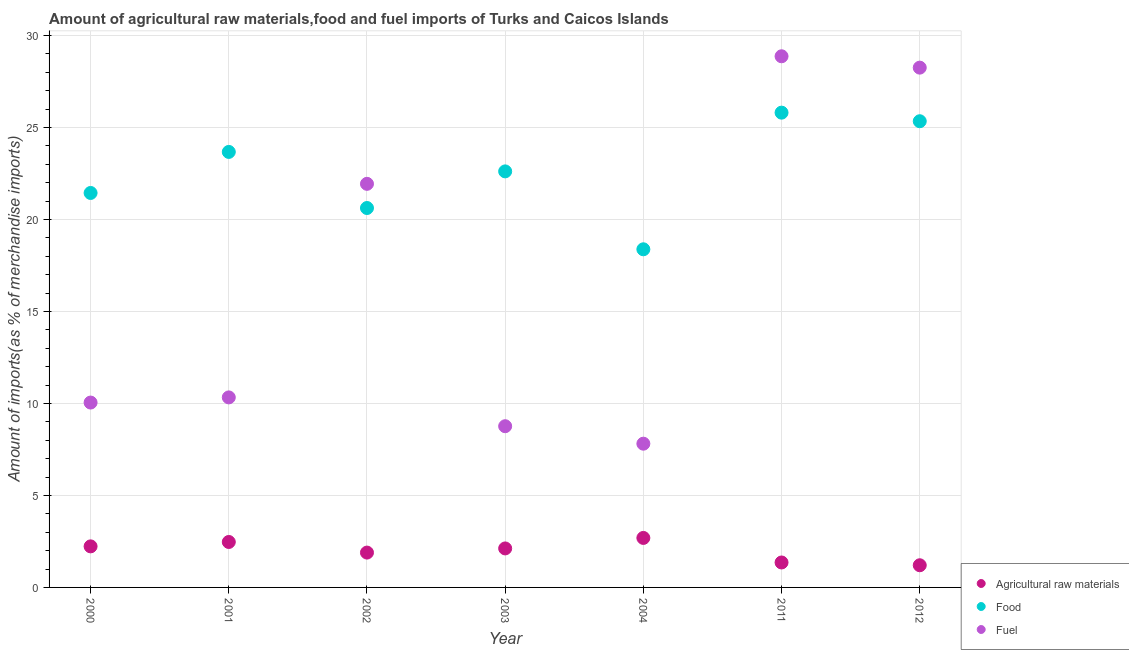How many different coloured dotlines are there?
Provide a succinct answer. 3. What is the percentage of raw materials imports in 2004?
Your answer should be compact. 2.69. Across all years, what is the maximum percentage of fuel imports?
Offer a very short reply. 28.87. Across all years, what is the minimum percentage of fuel imports?
Ensure brevity in your answer.  7.81. In which year was the percentage of fuel imports maximum?
Your response must be concise. 2011. What is the total percentage of raw materials imports in the graph?
Keep it short and to the point. 13.97. What is the difference between the percentage of raw materials imports in 2001 and that in 2011?
Provide a short and direct response. 1.11. What is the difference between the percentage of food imports in 2011 and the percentage of fuel imports in 2003?
Give a very brief answer. 17.04. What is the average percentage of raw materials imports per year?
Your answer should be compact. 2. In the year 2000, what is the difference between the percentage of raw materials imports and percentage of food imports?
Offer a terse response. -19.21. In how many years, is the percentage of fuel imports greater than 13 %?
Your answer should be compact. 3. What is the ratio of the percentage of fuel imports in 2002 to that in 2003?
Your answer should be compact. 2.5. Is the percentage of raw materials imports in 2000 less than that in 2002?
Give a very brief answer. No. What is the difference between the highest and the second highest percentage of raw materials imports?
Your response must be concise. 0.22. What is the difference between the highest and the lowest percentage of raw materials imports?
Offer a terse response. 1.49. In how many years, is the percentage of food imports greater than the average percentage of food imports taken over all years?
Your answer should be compact. 4. Does the percentage of fuel imports monotonically increase over the years?
Offer a very short reply. No. Is the percentage of raw materials imports strictly greater than the percentage of food imports over the years?
Your response must be concise. No. Is the percentage of raw materials imports strictly less than the percentage of fuel imports over the years?
Your response must be concise. Yes. How many dotlines are there?
Your response must be concise. 3. What is the difference between two consecutive major ticks on the Y-axis?
Give a very brief answer. 5. Are the values on the major ticks of Y-axis written in scientific E-notation?
Your answer should be very brief. No. Does the graph contain grids?
Your answer should be compact. Yes. What is the title of the graph?
Your answer should be compact. Amount of agricultural raw materials,food and fuel imports of Turks and Caicos Islands. What is the label or title of the Y-axis?
Provide a short and direct response. Amount of imports(as % of merchandise imports). What is the Amount of imports(as % of merchandise imports) in Agricultural raw materials in 2000?
Offer a terse response. 2.23. What is the Amount of imports(as % of merchandise imports) in Food in 2000?
Give a very brief answer. 21.44. What is the Amount of imports(as % of merchandise imports) of Fuel in 2000?
Give a very brief answer. 10.05. What is the Amount of imports(as % of merchandise imports) in Agricultural raw materials in 2001?
Give a very brief answer. 2.47. What is the Amount of imports(as % of merchandise imports) in Food in 2001?
Ensure brevity in your answer.  23.67. What is the Amount of imports(as % of merchandise imports) of Fuel in 2001?
Give a very brief answer. 10.33. What is the Amount of imports(as % of merchandise imports) of Agricultural raw materials in 2002?
Offer a terse response. 1.89. What is the Amount of imports(as % of merchandise imports) in Food in 2002?
Your answer should be very brief. 20.62. What is the Amount of imports(as % of merchandise imports) of Fuel in 2002?
Your answer should be compact. 21.94. What is the Amount of imports(as % of merchandise imports) of Agricultural raw materials in 2003?
Your answer should be compact. 2.12. What is the Amount of imports(as % of merchandise imports) in Food in 2003?
Ensure brevity in your answer.  22.62. What is the Amount of imports(as % of merchandise imports) of Fuel in 2003?
Your answer should be compact. 8.76. What is the Amount of imports(as % of merchandise imports) of Agricultural raw materials in 2004?
Ensure brevity in your answer.  2.69. What is the Amount of imports(as % of merchandise imports) in Food in 2004?
Offer a terse response. 18.38. What is the Amount of imports(as % of merchandise imports) in Fuel in 2004?
Make the answer very short. 7.81. What is the Amount of imports(as % of merchandise imports) in Agricultural raw materials in 2011?
Provide a short and direct response. 1.36. What is the Amount of imports(as % of merchandise imports) in Food in 2011?
Give a very brief answer. 25.81. What is the Amount of imports(as % of merchandise imports) of Fuel in 2011?
Provide a succinct answer. 28.87. What is the Amount of imports(as % of merchandise imports) in Agricultural raw materials in 2012?
Give a very brief answer. 1.21. What is the Amount of imports(as % of merchandise imports) in Food in 2012?
Offer a very short reply. 25.34. What is the Amount of imports(as % of merchandise imports) in Fuel in 2012?
Offer a very short reply. 28.25. Across all years, what is the maximum Amount of imports(as % of merchandise imports) in Agricultural raw materials?
Provide a succinct answer. 2.69. Across all years, what is the maximum Amount of imports(as % of merchandise imports) in Food?
Your answer should be compact. 25.81. Across all years, what is the maximum Amount of imports(as % of merchandise imports) of Fuel?
Your answer should be compact. 28.87. Across all years, what is the minimum Amount of imports(as % of merchandise imports) in Agricultural raw materials?
Give a very brief answer. 1.21. Across all years, what is the minimum Amount of imports(as % of merchandise imports) of Food?
Your response must be concise. 18.38. Across all years, what is the minimum Amount of imports(as % of merchandise imports) of Fuel?
Your response must be concise. 7.81. What is the total Amount of imports(as % of merchandise imports) in Agricultural raw materials in the graph?
Offer a very short reply. 13.97. What is the total Amount of imports(as % of merchandise imports) of Food in the graph?
Your answer should be compact. 157.88. What is the total Amount of imports(as % of merchandise imports) in Fuel in the graph?
Ensure brevity in your answer.  116.02. What is the difference between the Amount of imports(as % of merchandise imports) in Agricultural raw materials in 2000 and that in 2001?
Make the answer very short. -0.24. What is the difference between the Amount of imports(as % of merchandise imports) in Food in 2000 and that in 2001?
Offer a terse response. -2.23. What is the difference between the Amount of imports(as % of merchandise imports) of Fuel in 2000 and that in 2001?
Provide a succinct answer. -0.28. What is the difference between the Amount of imports(as % of merchandise imports) of Agricultural raw materials in 2000 and that in 2002?
Your answer should be compact. 0.34. What is the difference between the Amount of imports(as % of merchandise imports) of Food in 2000 and that in 2002?
Give a very brief answer. 0.82. What is the difference between the Amount of imports(as % of merchandise imports) of Fuel in 2000 and that in 2002?
Give a very brief answer. -11.89. What is the difference between the Amount of imports(as % of merchandise imports) of Agricultural raw materials in 2000 and that in 2003?
Provide a succinct answer. 0.11. What is the difference between the Amount of imports(as % of merchandise imports) in Food in 2000 and that in 2003?
Your answer should be compact. -1.17. What is the difference between the Amount of imports(as % of merchandise imports) in Fuel in 2000 and that in 2003?
Your answer should be very brief. 1.29. What is the difference between the Amount of imports(as % of merchandise imports) of Agricultural raw materials in 2000 and that in 2004?
Ensure brevity in your answer.  -0.46. What is the difference between the Amount of imports(as % of merchandise imports) of Food in 2000 and that in 2004?
Offer a terse response. 3.06. What is the difference between the Amount of imports(as % of merchandise imports) in Fuel in 2000 and that in 2004?
Your response must be concise. 2.24. What is the difference between the Amount of imports(as % of merchandise imports) in Agricultural raw materials in 2000 and that in 2011?
Give a very brief answer. 0.88. What is the difference between the Amount of imports(as % of merchandise imports) of Food in 2000 and that in 2011?
Offer a very short reply. -4.37. What is the difference between the Amount of imports(as % of merchandise imports) of Fuel in 2000 and that in 2011?
Offer a terse response. -18.82. What is the difference between the Amount of imports(as % of merchandise imports) in Agricultural raw materials in 2000 and that in 2012?
Give a very brief answer. 1.03. What is the difference between the Amount of imports(as % of merchandise imports) in Food in 2000 and that in 2012?
Your answer should be compact. -3.9. What is the difference between the Amount of imports(as % of merchandise imports) in Fuel in 2000 and that in 2012?
Ensure brevity in your answer.  -18.21. What is the difference between the Amount of imports(as % of merchandise imports) in Agricultural raw materials in 2001 and that in 2002?
Offer a terse response. 0.58. What is the difference between the Amount of imports(as % of merchandise imports) of Food in 2001 and that in 2002?
Provide a short and direct response. 3.05. What is the difference between the Amount of imports(as % of merchandise imports) of Fuel in 2001 and that in 2002?
Your answer should be very brief. -11.61. What is the difference between the Amount of imports(as % of merchandise imports) in Agricultural raw materials in 2001 and that in 2003?
Provide a short and direct response. 0.35. What is the difference between the Amount of imports(as % of merchandise imports) in Food in 2001 and that in 2003?
Ensure brevity in your answer.  1.06. What is the difference between the Amount of imports(as % of merchandise imports) in Fuel in 2001 and that in 2003?
Offer a very short reply. 1.57. What is the difference between the Amount of imports(as % of merchandise imports) of Agricultural raw materials in 2001 and that in 2004?
Keep it short and to the point. -0.22. What is the difference between the Amount of imports(as % of merchandise imports) in Food in 2001 and that in 2004?
Offer a terse response. 5.29. What is the difference between the Amount of imports(as % of merchandise imports) in Fuel in 2001 and that in 2004?
Your answer should be very brief. 2.52. What is the difference between the Amount of imports(as % of merchandise imports) in Agricultural raw materials in 2001 and that in 2011?
Provide a short and direct response. 1.11. What is the difference between the Amount of imports(as % of merchandise imports) of Food in 2001 and that in 2011?
Your response must be concise. -2.13. What is the difference between the Amount of imports(as % of merchandise imports) of Fuel in 2001 and that in 2011?
Offer a very short reply. -18.54. What is the difference between the Amount of imports(as % of merchandise imports) in Agricultural raw materials in 2001 and that in 2012?
Your answer should be compact. 1.27. What is the difference between the Amount of imports(as % of merchandise imports) in Food in 2001 and that in 2012?
Give a very brief answer. -1.67. What is the difference between the Amount of imports(as % of merchandise imports) of Fuel in 2001 and that in 2012?
Give a very brief answer. -17.93. What is the difference between the Amount of imports(as % of merchandise imports) of Agricultural raw materials in 2002 and that in 2003?
Your answer should be very brief. -0.23. What is the difference between the Amount of imports(as % of merchandise imports) in Food in 2002 and that in 2003?
Make the answer very short. -1.99. What is the difference between the Amount of imports(as % of merchandise imports) of Fuel in 2002 and that in 2003?
Keep it short and to the point. 13.18. What is the difference between the Amount of imports(as % of merchandise imports) in Agricultural raw materials in 2002 and that in 2004?
Keep it short and to the point. -0.8. What is the difference between the Amount of imports(as % of merchandise imports) in Food in 2002 and that in 2004?
Make the answer very short. 2.24. What is the difference between the Amount of imports(as % of merchandise imports) in Fuel in 2002 and that in 2004?
Keep it short and to the point. 14.13. What is the difference between the Amount of imports(as % of merchandise imports) of Agricultural raw materials in 2002 and that in 2011?
Provide a succinct answer. 0.54. What is the difference between the Amount of imports(as % of merchandise imports) of Food in 2002 and that in 2011?
Your response must be concise. -5.18. What is the difference between the Amount of imports(as % of merchandise imports) in Fuel in 2002 and that in 2011?
Provide a succinct answer. -6.93. What is the difference between the Amount of imports(as % of merchandise imports) in Agricultural raw materials in 2002 and that in 2012?
Ensure brevity in your answer.  0.69. What is the difference between the Amount of imports(as % of merchandise imports) of Food in 2002 and that in 2012?
Keep it short and to the point. -4.72. What is the difference between the Amount of imports(as % of merchandise imports) of Fuel in 2002 and that in 2012?
Make the answer very short. -6.32. What is the difference between the Amount of imports(as % of merchandise imports) of Agricultural raw materials in 2003 and that in 2004?
Your answer should be compact. -0.57. What is the difference between the Amount of imports(as % of merchandise imports) of Food in 2003 and that in 2004?
Provide a short and direct response. 4.23. What is the difference between the Amount of imports(as % of merchandise imports) in Fuel in 2003 and that in 2004?
Provide a short and direct response. 0.95. What is the difference between the Amount of imports(as % of merchandise imports) in Agricultural raw materials in 2003 and that in 2011?
Your answer should be compact. 0.76. What is the difference between the Amount of imports(as % of merchandise imports) of Food in 2003 and that in 2011?
Provide a succinct answer. -3.19. What is the difference between the Amount of imports(as % of merchandise imports) of Fuel in 2003 and that in 2011?
Provide a short and direct response. -20.11. What is the difference between the Amount of imports(as % of merchandise imports) of Agricultural raw materials in 2003 and that in 2012?
Offer a very short reply. 0.91. What is the difference between the Amount of imports(as % of merchandise imports) in Food in 2003 and that in 2012?
Give a very brief answer. -2.73. What is the difference between the Amount of imports(as % of merchandise imports) of Fuel in 2003 and that in 2012?
Make the answer very short. -19.49. What is the difference between the Amount of imports(as % of merchandise imports) in Agricultural raw materials in 2004 and that in 2011?
Provide a short and direct response. 1.33. What is the difference between the Amount of imports(as % of merchandise imports) of Food in 2004 and that in 2011?
Your response must be concise. -7.43. What is the difference between the Amount of imports(as % of merchandise imports) of Fuel in 2004 and that in 2011?
Offer a very short reply. -21.06. What is the difference between the Amount of imports(as % of merchandise imports) of Agricultural raw materials in 2004 and that in 2012?
Keep it short and to the point. 1.49. What is the difference between the Amount of imports(as % of merchandise imports) in Food in 2004 and that in 2012?
Provide a short and direct response. -6.96. What is the difference between the Amount of imports(as % of merchandise imports) in Fuel in 2004 and that in 2012?
Offer a very short reply. -20.44. What is the difference between the Amount of imports(as % of merchandise imports) in Agricultural raw materials in 2011 and that in 2012?
Your answer should be compact. 0.15. What is the difference between the Amount of imports(as % of merchandise imports) of Food in 2011 and that in 2012?
Provide a short and direct response. 0.47. What is the difference between the Amount of imports(as % of merchandise imports) of Fuel in 2011 and that in 2012?
Your response must be concise. 0.62. What is the difference between the Amount of imports(as % of merchandise imports) in Agricultural raw materials in 2000 and the Amount of imports(as % of merchandise imports) in Food in 2001?
Ensure brevity in your answer.  -21.44. What is the difference between the Amount of imports(as % of merchandise imports) in Agricultural raw materials in 2000 and the Amount of imports(as % of merchandise imports) in Fuel in 2001?
Make the answer very short. -8.1. What is the difference between the Amount of imports(as % of merchandise imports) of Food in 2000 and the Amount of imports(as % of merchandise imports) of Fuel in 2001?
Your answer should be very brief. 11.11. What is the difference between the Amount of imports(as % of merchandise imports) of Agricultural raw materials in 2000 and the Amount of imports(as % of merchandise imports) of Food in 2002?
Give a very brief answer. -18.39. What is the difference between the Amount of imports(as % of merchandise imports) in Agricultural raw materials in 2000 and the Amount of imports(as % of merchandise imports) in Fuel in 2002?
Offer a terse response. -19.71. What is the difference between the Amount of imports(as % of merchandise imports) of Food in 2000 and the Amount of imports(as % of merchandise imports) of Fuel in 2002?
Ensure brevity in your answer.  -0.5. What is the difference between the Amount of imports(as % of merchandise imports) in Agricultural raw materials in 2000 and the Amount of imports(as % of merchandise imports) in Food in 2003?
Make the answer very short. -20.38. What is the difference between the Amount of imports(as % of merchandise imports) of Agricultural raw materials in 2000 and the Amount of imports(as % of merchandise imports) of Fuel in 2003?
Give a very brief answer. -6.53. What is the difference between the Amount of imports(as % of merchandise imports) of Food in 2000 and the Amount of imports(as % of merchandise imports) of Fuel in 2003?
Offer a very short reply. 12.68. What is the difference between the Amount of imports(as % of merchandise imports) of Agricultural raw materials in 2000 and the Amount of imports(as % of merchandise imports) of Food in 2004?
Provide a short and direct response. -16.15. What is the difference between the Amount of imports(as % of merchandise imports) in Agricultural raw materials in 2000 and the Amount of imports(as % of merchandise imports) in Fuel in 2004?
Keep it short and to the point. -5.58. What is the difference between the Amount of imports(as % of merchandise imports) of Food in 2000 and the Amount of imports(as % of merchandise imports) of Fuel in 2004?
Provide a short and direct response. 13.63. What is the difference between the Amount of imports(as % of merchandise imports) of Agricultural raw materials in 2000 and the Amount of imports(as % of merchandise imports) of Food in 2011?
Provide a short and direct response. -23.58. What is the difference between the Amount of imports(as % of merchandise imports) in Agricultural raw materials in 2000 and the Amount of imports(as % of merchandise imports) in Fuel in 2011?
Your response must be concise. -26.64. What is the difference between the Amount of imports(as % of merchandise imports) in Food in 2000 and the Amount of imports(as % of merchandise imports) in Fuel in 2011?
Provide a short and direct response. -7.43. What is the difference between the Amount of imports(as % of merchandise imports) of Agricultural raw materials in 2000 and the Amount of imports(as % of merchandise imports) of Food in 2012?
Provide a short and direct response. -23.11. What is the difference between the Amount of imports(as % of merchandise imports) of Agricultural raw materials in 2000 and the Amount of imports(as % of merchandise imports) of Fuel in 2012?
Provide a short and direct response. -26.02. What is the difference between the Amount of imports(as % of merchandise imports) in Food in 2000 and the Amount of imports(as % of merchandise imports) in Fuel in 2012?
Your response must be concise. -6.81. What is the difference between the Amount of imports(as % of merchandise imports) of Agricultural raw materials in 2001 and the Amount of imports(as % of merchandise imports) of Food in 2002?
Your response must be concise. -18.15. What is the difference between the Amount of imports(as % of merchandise imports) in Agricultural raw materials in 2001 and the Amount of imports(as % of merchandise imports) in Fuel in 2002?
Provide a succinct answer. -19.47. What is the difference between the Amount of imports(as % of merchandise imports) of Food in 2001 and the Amount of imports(as % of merchandise imports) of Fuel in 2002?
Make the answer very short. 1.73. What is the difference between the Amount of imports(as % of merchandise imports) in Agricultural raw materials in 2001 and the Amount of imports(as % of merchandise imports) in Food in 2003?
Offer a terse response. -20.14. What is the difference between the Amount of imports(as % of merchandise imports) in Agricultural raw materials in 2001 and the Amount of imports(as % of merchandise imports) in Fuel in 2003?
Ensure brevity in your answer.  -6.29. What is the difference between the Amount of imports(as % of merchandise imports) of Food in 2001 and the Amount of imports(as % of merchandise imports) of Fuel in 2003?
Provide a short and direct response. 14.91. What is the difference between the Amount of imports(as % of merchandise imports) of Agricultural raw materials in 2001 and the Amount of imports(as % of merchandise imports) of Food in 2004?
Your response must be concise. -15.91. What is the difference between the Amount of imports(as % of merchandise imports) in Agricultural raw materials in 2001 and the Amount of imports(as % of merchandise imports) in Fuel in 2004?
Offer a very short reply. -5.34. What is the difference between the Amount of imports(as % of merchandise imports) in Food in 2001 and the Amount of imports(as % of merchandise imports) in Fuel in 2004?
Offer a terse response. 15.86. What is the difference between the Amount of imports(as % of merchandise imports) of Agricultural raw materials in 2001 and the Amount of imports(as % of merchandise imports) of Food in 2011?
Your response must be concise. -23.34. What is the difference between the Amount of imports(as % of merchandise imports) of Agricultural raw materials in 2001 and the Amount of imports(as % of merchandise imports) of Fuel in 2011?
Offer a very short reply. -26.4. What is the difference between the Amount of imports(as % of merchandise imports) of Food in 2001 and the Amount of imports(as % of merchandise imports) of Fuel in 2011?
Provide a succinct answer. -5.2. What is the difference between the Amount of imports(as % of merchandise imports) of Agricultural raw materials in 2001 and the Amount of imports(as % of merchandise imports) of Food in 2012?
Your response must be concise. -22.87. What is the difference between the Amount of imports(as % of merchandise imports) in Agricultural raw materials in 2001 and the Amount of imports(as % of merchandise imports) in Fuel in 2012?
Offer a terse response. -25.78. What is the difference between the Amount of imports(as % of merchandise imports) in Food in 2001 and the Amount of imports(as % of merchandise imports) in Fuel in 2012?
Offer a terse response. -4.58. What is the difference between the Amount of imports(as % of merchandise imports) of Agricultural raw materials in 2002 and the Amount of imports(as % of merchandise imports) of Food in 2003?
Keep it short and to the point. -20.72. What is the difference between the Amount of imports(as % of merchandise imports) in Agricultural raw materials in 2002 and the Amount of imports(as % of merchandise imports) in Fuel in 2003?
Your answer should be very brief. -6.87. What is the difference between the Amount of imports(as % of merchandise imports) in Food in 2002 and the Amount of imports(as % of merchandise imports) in Fuel in 2003?
Give a very brief answer. 11.86. What is the difference between the Amount of imports(as % of merchandise imports) of Agricultural raw materials in 2002 and the Amount of imports(as % of merchandise imports) of Food in 2004?
Make the answer very short. -16.49. What is the difference between the Amount of imports(as % of merchandise imports) of Agricultural raw materials in 2002 and the Amount of imports(as % of merchandise imports) of Fuel in 2004?
Make the answer very short. -5.92. What is the difference between the Amount of imports(as % of merchandise imports) in Food in 2002 and the Amount of imports(as % of merchandise imports) in Fuel in 2004?
Your answer should be very brief. 12.81. What is the difference between the Amount of imports(as % of merchandise imports) of Agricultural raw materials in 2002 and the Amount of imports(as % of merchandise imports) of Food in 2011?
Your answer should be very brief. -23.91. What is the difference between the Amount of imports(as % of merchandise imports) in Agricultural raw materials in 2002 and the Amount of imports(as % of merchandise imports) in Fuel in 2011?
Provide a succinct answer. -26.98. What is the difference between the Amount of imports(as % of merchandise imports) of Food in 2002 and the Amount of imports(as % of merchandise imports) of Fuel in 2011?
Your answer should be compact. -8.25. What is the difference between the Amount of imports(as % of merchandise imports) in Agricultural raw materials in 2002 and the Amount of imports(as % of merchandise imports) in Food in 2012?
Provide a short and direct response. -23.45. What is the difference between the Amount of imports(as % of merchandise imports) of Agricultural raw materials in 2002 and the Amount of imports(as % of merchandise imports) of Fuel in 2012?
Offer a terse response. -26.36. What is the difference between the Amount of imports(as % of merchandise imports) of Food in 2002 and the Amount of imports(as % of merchandise imports) of Fuel in 2012?
Provide a short and direct response. -7.63. What is the difference between the Amount of imports(as % of merchandise imports) of Agricultural raw materials in 2003 and the Amount of imports(as % of merchandise imports) of Food in 2004?
Offer a very short reply. -16.26. What is the difference between the Amount of imports(as % of merchandise imports) of Agricultural raw materials in 2003 and the Amount of imports(as % of merchandise imports) of Fuel in 2004?
Offer a very short reply. -5.69. What is the difference between the Amount of imports(as % of merchandise imports) of Food in 2003 and the Amount of imports(as % of merchandise imports) of Fuel in 2004?
Keep it short and to the point. 14.8. What is the difference between the Amount of imports(as % of merchandise imports) of Agricultural raw materials in 2003 and the Amount of imports(as % of merchandise imports) of Food in 2011?
Keep it short and to the point. -23.69. What is the difference between the Amount of imports(as % of merchandise imports) of Agricultural raw materials in 2003 and the Amount of imports(as % of merchandise imports) of Fuel in 2011?
Offer a very short reply. -26.75. What is the difference between the Amount of imports(as % of merchandise imports) in Food in 2003 and the Amount of imports(as % of merchandise imports) in Fuel in 2011?
Your answer should be very brief. -6.26. What is the difference between the Amount of imports(as % of merchandise imports) in Agricultural raw materials in 2003 and the Amount of imports(as % of merchandise imports) in Food in 2012?
Keep it short and to the point. -23.22. What is the difference between the Amount of imports(as % of merchandise imports) in Agricultural raw materials in 2003 and the Amount of imports(as % of merchandise imports) in Fuel in 2012?
Offer a very short reply. -26.13. What is the difference between the Amount of imports(as % of merchandise imports) in Food in 2003 and the Amount of imports(as % of merchandise imports) in Fuel in 2012?
Your answer should be compact. -5.64. What is the difference between the Amount of imports(as % of merchandise imports) in Agricultural raw materials in 2004 and the Amount of imports(as % of merchandise imports) in Food in 2011?
Give a very brief answer. -23.12. What is the difference between the Amount of imports(as % of merchandise imports) of Agricultural raw materials in 2004 and the Amount of imports(as % of merchandise imports) of Fuel in 2011?
Your answer should be very brief. -26.18. What is the difference between the Amount of imports(as % of merchandise imports) in Food in 2004 and the Amount of imports(as % of merchandise imports) in Fuel in 2011?
Provide a succinct answer. -10.49. What is the difference between the Amount of imports(as % of merchandise imports) of Agricultural raw materials in 2004 and the Amount of imports(as % of merchandise imports) of Food in 2012?
Keep it short and to the point. -22.65. What is the difference between the Amount of imports(as % of merchandise imports) in Agricultural raw materials in 2004 and the Amount of imports(as % of merchandise imports) in Fuel in 2012?
Ensure brevity in your answer.  -25.56. What is the difference between the Amount of imports(as % of merchandise imports) of Food in 2004 and the Amount of imports(as % of merchandise imports) of Fuel in 2012?
Your response must be concise. -9.87. What is the difference between the Amount of imports(as % of merchandise imports) of Agricultural raw materials in 2011 and the Amount of imports(as % of merchandise imports) of Food in 2012?
Offer a terse response. -23.99. What is the difference between the Amount of imports(as % of merchandise imports) in Agricultural raw materials in 2011 and the Amount of imports(as % of merchandise imports) in Fuel in 2012?
Your response must be concise. -26.9. What is the difference between the Amount of imports(as % of merchandise imports) in Food in 2011 and the Amount of imports(as % of merchandise imports) in Fuel in 2012?
Ensure brevity in your answer.  -2.45. What is the average Amount of imports(as % of merchandise imports) in Agricultural raw materials per year?
Give a very brief answer. 2. What is the average Amount of imports(as % of merchandise imports) of Food per year?
Your answer should be very brief. 22.55. What is the average Amount of imports(as % of merchandise imports) in Fuel per year?
Your response must be concise. 16.57. In the year 2000, what is the difference between the Amount of imports(as % of merchandise imports) of Agricultural raw materials and Amount of imports(as % of merchandise imports) of Food?
Provide a succinct answer. -19.21. In the year 2000, what is the difference between the Amount of imports(as % of merchandise imports) of Agricultural raw materials and Amount of imports(as % of merchandise imports) of Fuel?
Provide a succinct answer. -7.82. In the year 2000, what is the difference between the Amount of imports(as % of merchandise imports) of Food and Amount of imports(as % of merchandise imports) of Fuel?
Keep it short and to the point. 11.39. In the year 2001, what is the difference between the Amount of imports(as % of merchandise imports) of Agricultural raw materials and Amount of imports(as % of merchandise imports) of Food?
Give a very brief answer. -21.2. In the year 2001, what is the difference between the Amount of imports(as % of merchandise imports) of Agricultural raw materials and Amount of imports(as % of merchandise imports) of Fuel?
Make the answer very short. -7.86. In the year 2001, what is the difference between the Amount of imports(as % of merchandise imports) in Food and Amount of imports(as % of merchandise imports) in Fuel?
Give a very brief answer. 13.34. In the year 2002, what is the difference between the Amount of imports(as % of merchandise imports) in Agricultural raw materials and Amount of imports(as % of merchandise imports) in Food?
Offer a terse response. -18.73. In the year 2002, what is the difference between the Amount of imports(as % of merchandise imports) in Agricultural raw materials and Amount of imports(as % of merchandise imports) in Fuel?
Keep it short and to the point. -20.04. In the year 2002, what is the difference between the Amount of imports(as % of merchandise imports) in Food and Amount of imports(as % of merchandise imports) in Fuel?
Your response must be concise. -1.31. In the year 2003, what is the difference between the Amount of imports(as % of merchandise imports) of Agricultural raw materials and Amount of imports(as % of merchandise imports) of Food?
Provide a succinct answer. -20.5. In the year 2003, what is the difference between the Amount of imports(as % of merchandise imports) of Agricultural raw materials and Amount of imports(as % of merchandise imports) of Fuel?
Provide a succinct answer. -6.64. In the year 2003, what is the difference between the Amount of imports(as % of merchandise imports) in Food and Amount of imports(as % of merchandise imports) in Fuel?
Ensure brevity in your answer.  13.85. In the year 2004, what is the difference between the Amount of imports(as % of merchandise imports) in Agricultural raw materials and Amount of imports(as % of merchandise imports) in Food?
Give a very brief answer. -15.69. In the year 2004, what is the difference between the Amount of imports(as % of merchandise imports) of Agricultural raw materials and Amount of imports(as % of merchandise imports) of Fuel?
Your response must be concise. -5.12. In the year 2004, what is the difference between the Amount of imports(as % of merchandise imports) of Food and Amount of imports(as % of merchandise imports) of Fuel?
Offer a very short reply. 10.57. In the year 2011, what is the difference between the Amount of imports(as % of merchandise imports) of Agricultural raw materials and Amount of imports(as % of merchandise imports) of Food?
Keep it short and to the point. -24.45. In the year 2011, what is the difference between the Amount of imports(as % of merchandise imports) in Agricultural raw materials and Amount of imports(as % of merchandise imports) in Fuel?
Provide a short and direct response. -27.52. In the year 2011, what is the difference between the Amount of imports(as % of merchandise imports) in Food and Amount of imports(as % of merchandise imports) in Fuel?
Your answer should be very brief. -3.06. In the year 2012, what is the difference between the Amount of imports(as % of merchandise imports) in Agricultural raw materials and Amount of imports(as % of merchandise imports) in Food?
Provide a succinct answer. -24.14. In the year 2012, what is the difference between the Amount of imports(as % of merchandise imports) in Agricultural raw materials and Amount of imports(as % of merchandise imports) in Fuel?
Keep it short and to the point. -27.05. In the year 2012, what is the difference between the Amount of imports(as % of merchandise imports) of Food and Amount of imports(as % of merchandise imports) of Fuel?
Your answer should be very brief. -2.91. What is the ratio of the Amount of imports(as % of merchandise imports) of Agricultural raw materials in 2000 to that in 2001?
Offer a terse response. 0.9. What is the ratio of the Amount of imports(as % of merchandise imports) in Food in 2000 to that in 2001?
Provide a short and direct response. 0.91. What is the ratio of the Amount of imports(as % of merchandise imports) in Fuel in 2000 to that in 2001?
Make the answer very short. 0.97. What is the ratio of the Amount of imports(as % of merchandise imports) in Agricultural raw materials in 2000 to that in 2002?
Your response must be concise. 1.18. What is the ratio of the Amount of imports(as % of merchandise imports) in Food in 2000 to that in 2002?
Offer a terse response. 1.04. What is the ratio of the Amount of imports(as % of merchandise imports) of Fuel in 2000 to that in 2002?
Your answer should be very brief. 0.46. What is the ratio of the Amount of imports(as % of merchandise imports) of Agricultural raw materials in 2000 to that in 2003?
Your response must be concise. 1.05. What is the ratio of the Amount of imports(as % of merchandise imports) of Food in 2000 to that in 2003?
Keep it short and to the point. 0.95. What is the ratio of the Amount of imports(as % of merchandise imports) of Fuel in 2000 to that in 2003?
Your answer should be very brief. 1.15. What is the ratio of the Amount of imports(as % of merchandise imports) of Agricultural raw materials in 2000 to that in 2004?
Offer a very short reply. 0.83. What is the ratio of the Amount of imports(as % of merchandise imports) of Food in 2000 to that in 2004?
Make the answer very short. 1.17. What is the ratio of the Amount of imports(as % of merchandise imports) in Fuel in 2000 to that in 2004?
Ensure brevity in your answer.  1.29. What is the ratio of the Amount of imports(as % of merchandise imports) in Agricultural raw materials in 2000 to that in 2011?
Provide a succinct answer. 1.65. What is the ratio of the Amount of imports(as % of merchandise imports) in Food in 2000 to that in 2011?
Your response must be concise. 0.83. What is the ratio of the Amount of imports(as % of merchandise imports) in Fuel in 2000 to that in 2011?
Provide a short and direct response. 0.35. What is the ratio of the Amount of imports(as % of merchandise imports) of Agricultural raw materials in 2000 to that in 2012?
Give a very brief answer. 1.85. What is the ratio of the Amount of imports(as % of merchandise imports) of Food in 2000 to that in 2012?
Offer a terse response. 0.85. What is the ratio of the Amount of imports(as % of merchandise imports) in Fuel in 2000 to that in 2012?
Keep it short and to the point. 0.36. What is the ratio of the Amount of imports(as % of merchandise imports) in Agricultural raw materials in 2001 to that in 2002?
Your answer should be very brief. 1.3. What is the ratio of the Amount of imports(as % of merchandise imports) of Food in 2001 to that in 2002?
Offer a very short reply. 1.15. What is the ratio of the Amount of imports(as % of merchandise imports) of Fuel in 2001 to that in 2002?
Keep it short and to the point. 0.47. What is the ratio of the Amount of imports(as % of merchandise imports) in Agricultural raw materials in 2001 to that in 2003?
Give a very brief answer. 1.17. What is the ratio of the Amount of imports(as % of merchandise imports) of Food in 2001 to that in 2003?
Give a very brief answer. 1.05. What is the ratio of the Amount of imports(as % of merchandise imports) of Fuel in 2001 to that in 2003?
Your answer should be very brief. 1.18. What is the ratio of the Amount of imports(as % of merchandise imports) of Agricultural raw materials in 2001 to that in 2004?
Your answer should be compact. 0.92. What is the ratio of the Amount of imports(as % of merchandise imports) in Food in 2001 to that in 2004?
Ensure brevity in your answer.  1.29. What is the ratio of the Amount of imports(as % of merchandise imports) in Fuel in 2001 to that in 2004?
Ensure brevity in your answer.  1.32. What is the ratio of the Amount of imports(as % of merchandise imports) in Agricultural raw materials in 2001 to that in 2011?
Give a very brief answer. 1.82. What is the ratio of the Amount of imports(as % of merchandise imports) of Food in 2001 to that in 2011?
Your answer should be compact. 0.92. What is the ratio of the Amount of imports(as % of merchandise imports) in Fuel in 2001 to that in 2011?
Your answer should be compact. 0.36. What is the ratio of the Amount of imports(as % of merchandise imports) in Agricultural raw materials in 2001 to that in 2012?
Ensure brevity in your answer.  2.05. What is the ratio of the Amount of imports(as % of merchandise imports) in Food in 2001 to that in 2012?
Your answer should be very brief. 0.93. What is the ratio of the Amount of imports(as % of merchandise imports) of Fuel in 2001 to that in 2012?
Provide a short and direct response. 0.37. What is the ratio of the Amount of imports(as % of merchandise imports) of Agricultural raw materials in 2002 to that in 2003?
Give a very brief answer. 0.89. What is the ratio of the Amount of imports(as % of merchandise imports) of Food in 2002 to that in 2003?
Provide a succinct answer. 0.91. What is the ratio of the Amount of imports(as % of merchandise imports) in Fuel in 2002 to that in 2003?
Keep it short and to the point. 2.5. What is the ratio of the Amount of imports(as % of merchandise imports) in Agricultural raw materials in 2002 to that in 2004?
Your response must be concise. 0.7. What is the ratio of the Amount of imports(as % of merchandise imports) of Food in 2002 to that in 2004?
Offer a terse response. 1.12. What is the ratio of the Amount of imports(as % of merchandise imports) in Fuel in 2002 to that in 2004?
Keep it short and to the point. 2.81. What is the ratio of the Amount of imports(as % of merchandise imports) in Agricultural raw materials in 2002 to that in 2011?
Give a very brief answer. 1.4. What is the ratio of the Amount of imports(as % of merchandise imports) in Food in 2002 to that in 2011?
Make the answer very short. 0.8. What is the ratio of the Amount of imports(as % of merchandise imports) in Fuel in 2002 to that in 2011?
Your response must be concise. 0.76. What is the ratio of the Amount of imports(as % of merchandise imports) of Agricultural raw materials in 2002 to that in 2012?
Your response must be concise. 1.57. What is the ratio of the Amount of imports(as % of merchandise imports) in Food in 2002 to that in 2012?
Offer a very short reply. 0.81. What is the ratio of the Amount of imports(as % of merchandise imports) of Fuel in 2002 to that in 2012?
Your answer should be compact. 0.78. What is the ratio of the Amount of imports(as % of merchandise imports) in Agricultural raw materials in 2003 to that in 2004?
Make the answer very short. 0.79. What is the ratio of the Amount of imports(as % of merchandise imports) of Food in 2003 to that in 2004?
Provide a succinct answer. 1.23. What is the ratio of the Amount of imports(as % of merchandise imports) of Fuel in 2003 to that in 2004?
Offer a terse response. 1.12. What is the ratio of the Amount of imports(as % of merchandise imports) in Agricultural raw materials in 2003 to that in 2011?
Keep it short and to the point. 1.56. What is the ratio of the Amount of imports(as % of merchandise imports) of Food in 2003 to that in 2011?
Give a very brief answer. 0.88. What is the ratio of the Amount of imports(as % of merchandise imports) of Fuel in 2003 to that in 2011?
Provide a succinct answer. 0.3. What is the ratio of the Amount of imports(as % of merchandise imports) in Agricultural raw materials in 2003 to that in 2012?
Offer a very short reply. 1.76. What is the ratio of the Amount of imports(as % of merchandise imports) of Food in 2003 to that in 2012?
Give a very brief answer. 0.89. What is the ratio of the Amount of imports(as % of merchandise imports) in Fuel in 2003 to that in 2012?
Provide a short and direct response. 0.31. What is the ratio of the Amount of imports(as % of merchandise imports) in Agricultural raw materials in 2004 to that in 2011?
Your answer should be compact. 1.98. What is the ratio of the Amount of imports(as % of merchandise imports) of Food in 2004 to that in 2011?
Make the answer very short. 0.71. What is the ratio of the Amount of imports(as % of merchandise imports) in Fuel in 2004 to that in 2011?
Keep it short and to the point. 0.27. What is the ratio of the Amount of imports(as % of merchandise imports) of Agricultural raw materials in 2004 to that in 2012?
Provide a succinct answer. 2.23. What is the ratio of the Amount of imports(as % of merchandise imports) of Food in 2004 to that in 2012?
Your answer should be very brief. 0.73. What is the ratio of the Amount of imports(as % of merchandise imports) of Fuel in 2004 to that in 2012?
Provide a short and direct response. 0.28. What is the ratio of the Amount of imports(as % of merchandise imports) of Agricultural raw materials in 2011 to that in 2012?
Offer a very short reply. 1.13. What is the ratio of the Amount of imports(as % of merchandise imports) of Food in 2011 to that in 2012?
Offer a very short reply. 1.02. What is the ratio of the Amount of imports(as % of merchandise imports) of Fuel in 2011 to that in 2012?
Provide a short and direct response. 1.02. What is the difference between the highest and the second highest Amount of imports(as % of merchandise imports) in Agricultural raw materials?
Give a very brief answer. 0.22. What is the difference between the highest and the second highest Amount of imports(as % of merchandise imports) of Food?
Offer a very short reply. 0.47. What is the difference between the highest and the second highest Amount of imports(as % of merchandise imports) in Fuel?
Provide a succinct answer. 0.62. What is the difference between the highest and the lowest Amount of imports(as % of merchandise imports) in Agricultural raw materials?
Give a very brief answer. 1.49. What is the difference between the highest and the lowest Amount of imports(as % of merchandise imports) in Food?
Give a very brief answer. 7.43. What is the difference between the highest and the lowest Amount of imports(as % of merchandise imports) of Fuel?
Ensure brevity in your answer.  21.06. 